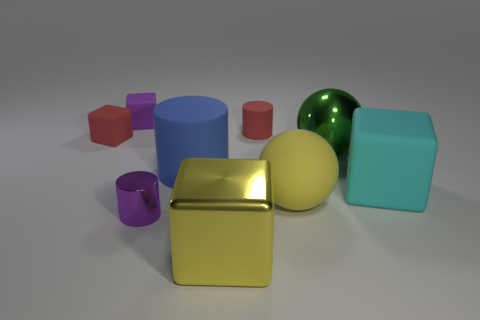What is the shape of the yellow matte thing?
Provide a succinct answer. Sphere. Is the metal block the same color as the big matte sphere?
Keep it short and to the point. Yes. What color is the matte cube that is the same size as the blue object?
Your response must be concise. Cyan. What number of purple objects are either metallic objects or big metal spheres?
Provide a short and direct response. 1. Is the number of big cylinders greater than the number of big gray matte things?
Provide a short and direct response. Yes. There is a cylinder that is right of the blue object; is it the same size as the matte cylinder that is in front of the red matte block?
Keep it short and to the point. No. The rubber block that is right of the tiny purple thing that is in front of the cube left of the tiny purple rubber block is what color?
Your answer should be very brief. Cyan. Are there any small green things of the same shape as the yellow rubber object?
Ensure brevity in your answer.  No. Is the number of blue cylinders that are behind the cyan rubber object greater than the number of small red things?
Give a very brief answer. No. How many rubber things are small red blocks or cyan blocks?
Offer a very short reply. 2. 